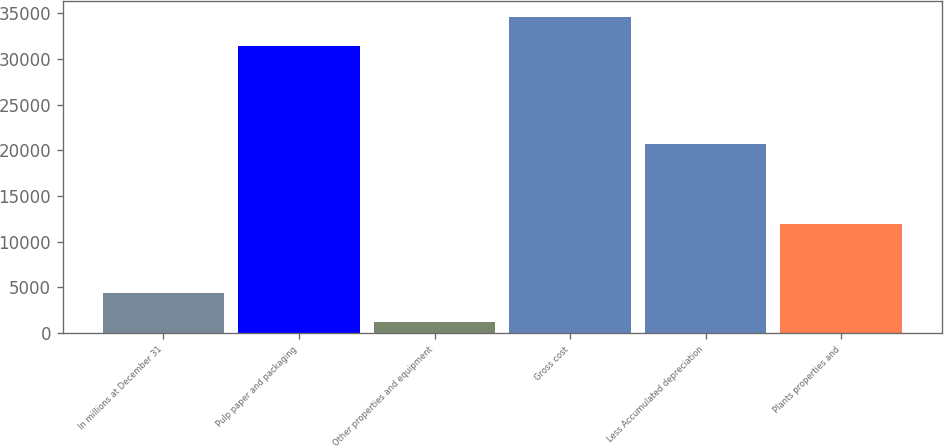Convert chart. <chart><loc_0><loc_0><loc_500><loc_500><bar_chart><fcel>In millions at December 31<fcel>Pulp paper and packaging<fcel>Other properties and equipment<fcel>Gross cost<fcel>Less Accumulated depreciation<fcel>Plants properties and<nl><fcel>4388.6<fcel>31466<fcel>1242<fcel>34612.6<fcel>20728<fcel>11980<nl></chart> 